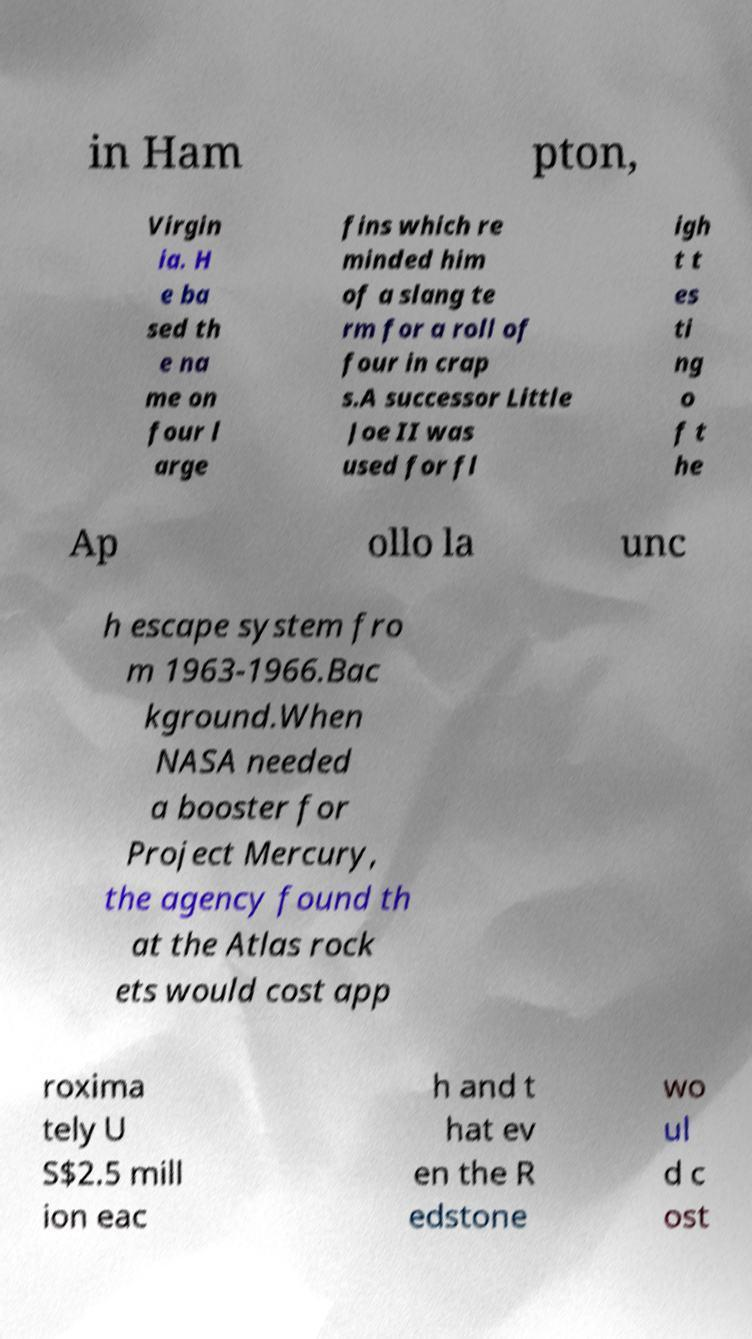There's text embedded in this image that I need extracted. Can you transcribe it verbatim? in Ham pton, Virgin ia. H e ba sed th e na me on four l arge fins which re minded him of a slang te rm for a roll of four in crap s.A successor Little Joe II was used for fl igh t t es ti ng o f t he Ap ollo la unc h escape system fro m 1963-1966.Bac kground.When NASA needed a booster for Project Mercury, the agency found th at the Atlas rock ets would cost app roxima tely U S$2.5 mill ion eac h and t hat ev en the R edstone wo ul d c ost 